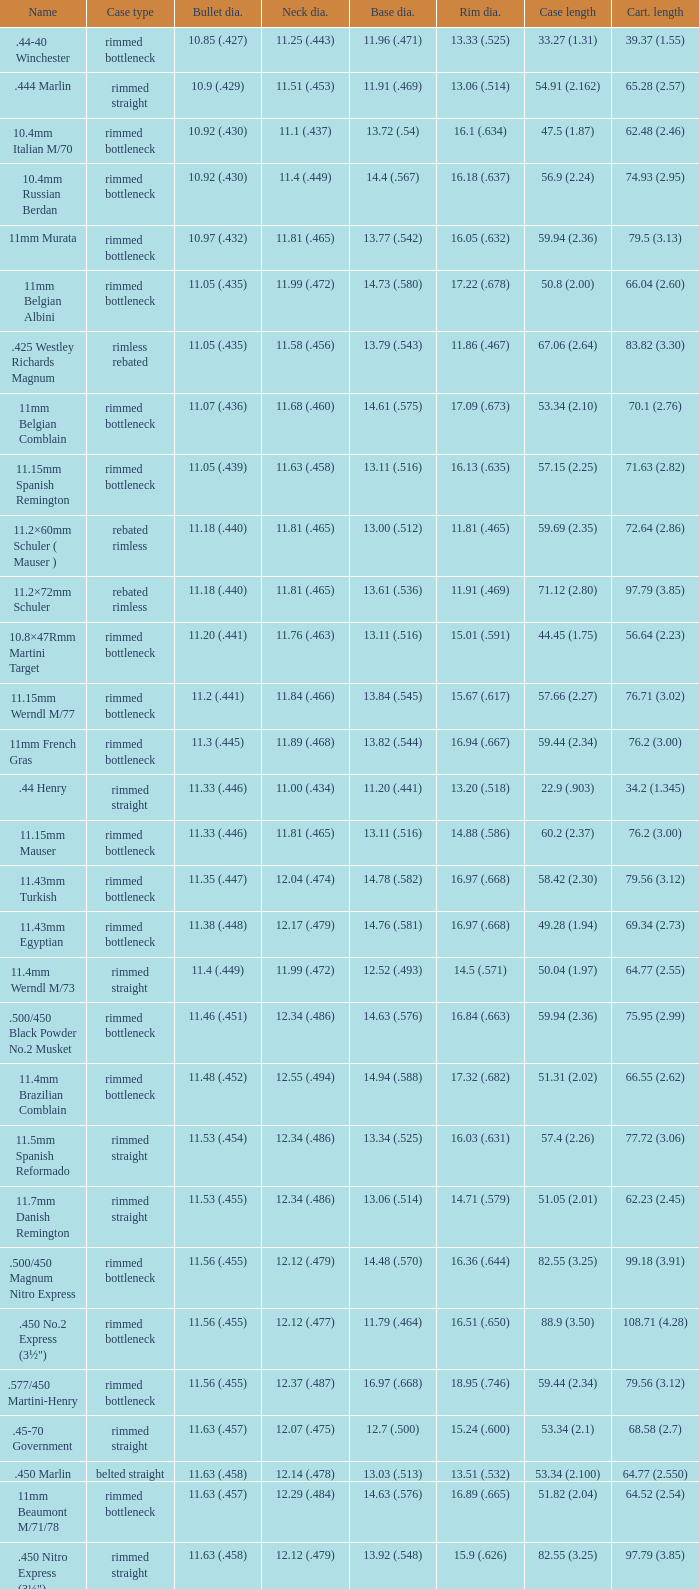Could you parse the entire table as a dict? {'header': ['Name', 'Case type', 'Bullet dia.', 'Neck dia.', 'Base dia.', 'Rim dia.', 'Case length', 'Cart. length'], 'rows': [['.44-40 Winchester', 'rimmed bottleneck', '10.85 (.427)', '11.25 (.443)', '11.96 (.471)', '13.33 (.525)', '33.27 (1.31)', '39.37 (1.55)'], ['.444 Marlin', 'rimmed straight', '10.9 (.429)', '11.51 (.453)', '11.91 (.469)', '13.06 (.514)', '54.91 (2.162)', '65.28 (2.57)'], ['10.4mm Italian M/70', 'rimmed bottleneck', '10.92 (.430)', '11.1 (.437)', '13.72 (.54)', '16.1 (.634)', '47.5 (1.87)', '62.48 (2.46)'], ['10.4mm Russian Berdan', 'rimmed bottleneck', '10.92 (.430)', '11.4 (.449)', '14.4 (.567)', '16.18 (.637)', '56.9 (2.24)', '74.93 (2.95)'], ['11mm Murata', 'rimmed bottleneck', '10.97 (.432)', '11.81 (.465)', '13.77 (.542)', '16.05 (.632)', '59.94 (2.36)', '79.5 (3.13)'], ['11mm Belgian Albini', 'rimmed bottleneck', '11.05 (.435)', '11.99 (.472)', '14.73 (.580)', '17.22 (.678)', '50.8 (2.00)', '66.04 (2.60)'], ['.425 Westley Richards Magnum', 'rimless rebated', '11.05 (.435)', '11.58 (.456)', '13.79 (.543)', '11.86 (.467)', '67.06 (2.64)', '83.82 (3.30)'], ['11mm Belgian Comblain', 'rimmed bottleneck', '11.07 (.436)', '11.68 (.460)', '14.61 (.575)', '17.09 (.673)', '53.34 (2.10)', '70.1 (2.76)'], ['11.15mm Spanish Remington', 'rimmed bottleneck', '11.05 (.439)', '11.63 (.458)', '13.11 (.516)', '16.13 (.635)', '57.15 (2.25)', '71.63 (2.82)'], ['11.2×60mm Schuler ( Mauser )', 'rebated rimless', '11.18 (.440)', '11.81 (.465)', '13.00 (.512)', '11.81 (.465)', '59.69 (2.35)', '72.64 (2.86)'], ['11.2×72mm Schuler', 'rebated rimless', '11.18 (.440)', '11.81 (.465)', '13.61 (.536)', '11.91 (.469)', '71.12 (2.80)', '97.79 (3.85)'], ['10.8×47Rmm Martini Target', 'rimmed bottleneck', '11.20 (.441)', '11.76 (.463)', '13.11 (.516)', '15.01 (.591)', '44.45 (1.75)', '56.64 (2.23)'], ['11.15mm Werndl M/77', 'rimmed bottleneck', '11.2 (.441)', '11.84 (.466)', '13.84 (.545)', '15.67 (.617)', '57.66 (2.27)', '76.71 (3.02)'], ['11mm French Gras', 'rimmed bottleneck', '11.3 (.445)', '11.89 (.468)', '13.82 (.544)', '16.94 (.667)', '59.44 (2.34)', '76.2 (3.00)'], ['.44 Henry', 'rimmed straight', '11.33 (.446)', '11.00 (.434)', '11.20 (.441)', '13.20 (.518)', '22.9 (.903)', '34.2 (1.345)'], ['11.15mm Mauser', 'rimmed bottleneck', '11.33 (.446)', '11.81 (.465)', '13.11 (.516)', '14.88 (.586)', '60.2 (2.37)', '76.2 (3.00)'], ['11.43mm Turkish', 'rimmed bottleneck', '11.35 (.447)', '12.04 (.474)', '14.78 (.582)', '16.97 (.668)', '58.42 (2.30)', '79.56 (3.12)'], ['11.43mm Egyptian', 'rimmed bottleneck', '11.38 (.448)', '12.17 (.479)', '14.76 (.581)', '16.97 (.668)', '49.28 (1.94)', '69.34 (2.73)'], ['11.4mm Werndl M/73', 'rimmed straight', '11.4 (.449)', '11.99 (.472)', '12.52 (.493)', '14.5 (.571)', '50.04 (1.97)', '64.77 (2.55)'], ['.500/450 Black Powder No.2 Musket', 'rimmed bottleneck', '11.46 (.451)', '12.34 (.486)', '14.63 (.576)', '16.84 (.663)', '59.94 (2.36)', '75.95 (2.99)'], ['11.4mm Brazilian Comblain', 'rimmed bottleneck', '11.48 (.452)', '12.55 (.494)', '14.94 (.588)', '17.32 (.682)', '51.31 (2.02)', '66.55 (2.62)'], ['11.5mm Spanish Reformado', 'rimmed straight', '11.53 (.454)', '12.34 (.486)', '13.34 (.525)', '16.03 (.631)', '57.4 (2.26)', '77.72 (3.06)'], ['11.7mm Danish Remington', 'rimmed straight', '11.53 (.455)', '12.34 (.486)', '13.06 (.514)', '14.71 (.579)', '51.05 (2.01)', '62.23 (2.45)'], ['.500/450 Magnum Nitro Express', 'rimmed bottleneck', '11.56 (.455)', '12.12 (.479)', '14.48 (.570)', '16.36 (.644)', '82.55 (3.25)', '99.18 (3.91)'], ['.450 No.2 Express (3½")', 'rimmed bottleneck', '11.56 (.455)', '12.12 (.477)', '11.79 (.464)', '16.51 (.650)', '88.9 (3.50)', '108.71 (4.28)'], ['.577/450 Martini-Henry', 'rimmed bottleneck', '11.56 (.455)', '12.37 (.487)', '16.97 (.668)', '18.95 (.746)', '59.44 (2.34)', '79.56 (3.12)'], ['.45-70 Government', 'rimmed straight', '11.63 (.457)', '12.07 (.475)', '12.7 (.500)', '15.24 (.600)', '53.34 (2.1)', '68.58 (2.7)'], ['.450 Marlin', 'belted straight', '11.63 (.458)', '12.14 (.478)', '13.03 (.513)', '13.51 (.532)', '53.34 (2.100)', '64.77 (2.550)'], ['11mm Beaumont M/71/78', 'rimmed bottleneck', '11.63 (.457)', '12.29 (.484)', '14.63 (.576)', '16.89 (.665)', '51.82 (2.04)', '64.52 (2.54)'], ['.450 Nitro Express (3¼")', 'rimmed straight', '11.63 (.458)', '12.12 (.479)', '13.92 (.548)', '15.9 (.626)', '82.55 (3.25)', '97.79 (3.85)'], ['.458 Winchester Magnum', 'belted straight', '11.63 (.458)', '12.14 (.478)', '13.03 (.513)', '13.51 (.532)', '63.5 (2.5)', '82.55 (3.350)'], ['.460 Weatherby Magnum', 'belted bottleneck', '11.63 (.458)', '12.32 (.485)', '14.80 (.583)', '13.54 (.533)', '74 (2.91)', '95.25 (3.75)'], ['.500/450 No.1 Express', 'rimmed bottleneck', '11.63 (.458)', '12.32 (.485)', '14.66 (.577)', '16.76 (.660)', '69.85 (2.75)', '82.55 (3.25)'], ['.450 Rigby Rimless', 'rimless bottleneck', '11.63 (.458)', '12.38 (.487)', '14.66 (.577)', '14.99 (.590)', '73.50 (2.89)', '95.00 (3.74)'], ['11.3mm Beaumont M/71', 'rimmed bottleneck', '11.63 (.464)', '12.34 (.486)', '14.76 (.581)', '16.92 (.666)', '50.04 (1.97)', '63.25 (2.49)'], ['.500/465 Nitro Express', 'rimmed bottleneck', '11.84 (.466)', '12.39 (.488)', '14.55 (.573)', '16.51 (.650)', '82.3 (3.24)', '98.04 (3.89)']]} Which Case type has a Cartridge length of 64.77 (2.550)? Belted straight. 